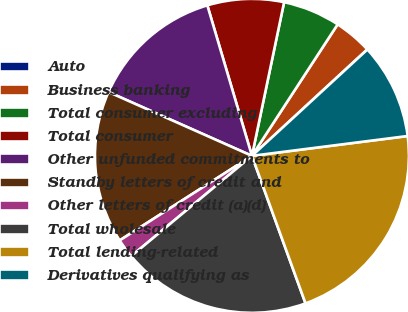Convert chart to OTSL. <chart><loc_0><loc_0><loc_500><loc_500><pie_chart><fcel>Auto<fcel>Business banking<fcel>Total consumer excluding<fcel>Total consumer<fcel>Other unfunded commitments to<fcel>Standby letters of credit and<fcel>Other letters of credit (a)(d)<fcel>Total wholesale<fcel>Total lending-related<fcel>Derivatives qualifying as<nl><fcel>0.02%<fcel>3.94%<fcel>5.91%<fcel>7.87%<fcel>13.75%<fcel>15.72%<fcel>1.98%<fcel>19.51%<fcel>21.47%<fcel>9.83%<nl></chart> 